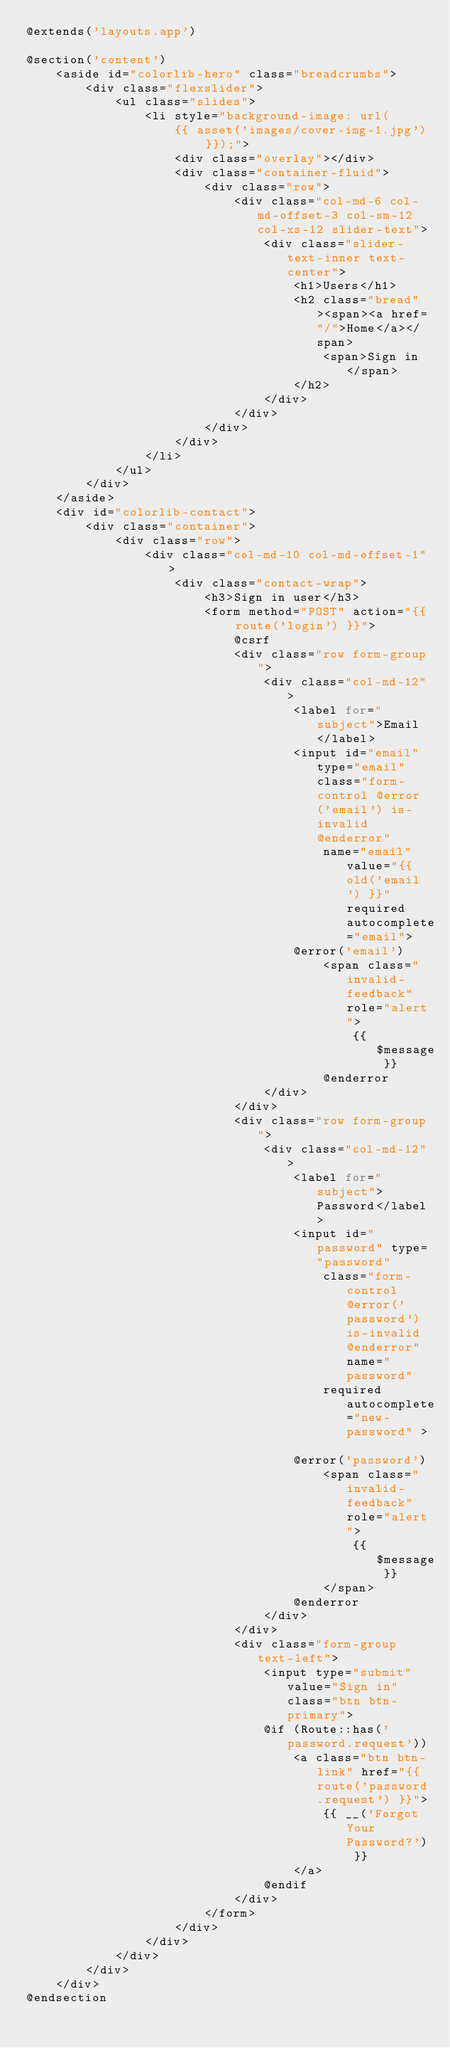Convert code to text. <code><loc_0><loc_0><loc_500><loc_500><_PHP_>@extends('layouts.app')

@section('content')
    <aside id="colorlib-hero" class="breadcrumbs">
        <div class="flexslider">
            <ul class="slides">
                <li style="background-image: url(
                    {{ asset('images/cover-img-1.jpg') }});">
                    <div class="overlay"></div>
                    <div class="container-fluid">
                        <div class="row">
                            <div class="col-md-6 col-md-offset-3 col-sm-12 col-xs-12 slider-text">
                                <div class="slider-text-inner text-center">
                                    <h1>Users</h1>
                                    <h2 class="bread"><span><a href="/">Home</a></span>
                                        <span>Sign in</span>
                                    </h2>
                                </div>
                            </div>
                        </div>
                    </div>
                </li>
            </ul>
        </div>
    </aside>
    <div id="colorlib-contact">
        <div class="container">
            <div class="row">
                <div class="col-md-10 col-md-offset-1">
                    <div class="contact-wrap">
                        <h3>Sign in user</h3>
                        <form method="POST" action="{{ route('login') }}">
                            @csrf
                            <div class="row form-group">
                                <div class="col-md-12">
                                    <label for="subject">Email</label>
                                    <input id="email" type="email" class="form-control @error('email') is-invalid @enderror"
                                        name="email" value="{{ old('email') }}" required autocomplete="email">
                                    @error('email')
                                        <span class="invalid-feedback" role="alert">
                                            {{ $message }}
                                        @enderror
                                </div>
                            </div>
                            <div class="row form-group">
                                <div class="col-md-12">
                                    <label for="subject">Password</label>
                                    <input id="password" type="password"
                                        class="form-control @error('password') is-invalid @enderror" name="password"
                                        required autocomplete="new-password" >

                                    @error('password')
                                        <span class="invalid-feedback" role="alert">
                                            {{ $message }}
                                        </span>
                                    @enderror
                                </div>
                            </div>
                            <div class="form-group text-left">
                                <input type="submit" value="Sign in" class="btn btn-primary">
                                @if (Route::has('password.request'))
                                    <a class="btn btn-link" href="{{ route('password.request') }}">
                                        {{ __('Forgot Your Password?') }}
                                    </a>
                                @endif
                            </div>
                        </form>
                    </div>
                </div>
            </div>
        </div>
    </div>
@endsection
</code> 